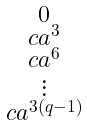Convert formula to latex. <formula><loc_0><loc_0><loc_500><loc_500>\begin{smallmatrix} 0 \\ c a ^ { 3 } \\ c a ^ { 6 } \\ \vdots \\ c a ^ { 3 ( q - 1 ) } \end{smallmatrix}</formula> 